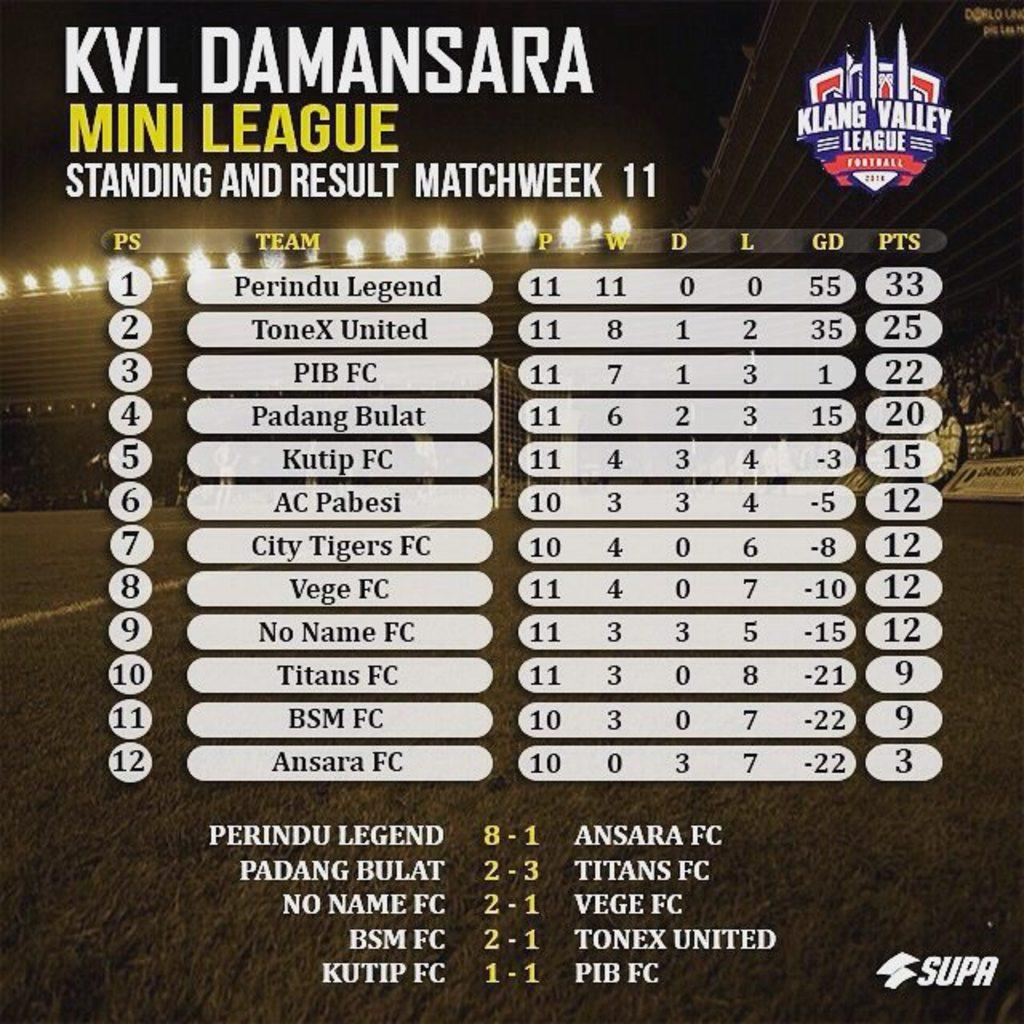<image>
Render a clear and concise summary of the photo. Klaang valley mini leauge standing and result matchweek 11 . 